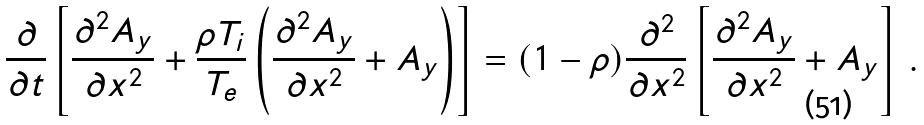<formula> <loc_0><loc_0><loc_500><loc_500>\frac { \partial } { \partial t } \left [ \frac { \partial ^ { 2 } A _ { y } } { \partial x ^ { 2 } } + \frac { \rho T _ { i } } { T _ { e } } \left ( \frac { \partial ^ { 2 } A _ { y } } { \partial x ^ { 2 } } + A _ { y } \right ) \right ] = ( 1 - \rho ) \frac { \partial ^ { 2 } } { \partial x ^ { 2 } } \left [ \frac { \partial ^ { 2 } A _ { y } } { \partial x ^ { 2 } } + A _ { y } \right ] \, .</formula> 